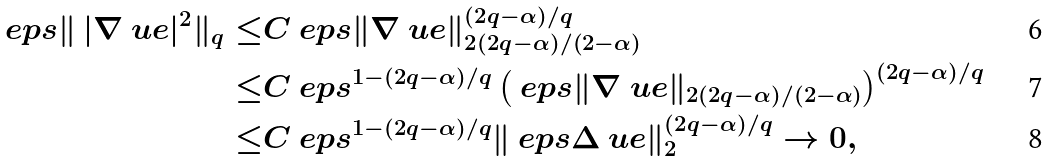Convert formula to latex. <formula><loc_0><loc_0><loc_500><loc_500>\ e p s \| \, | \nabla \ u e | ^ { 2 } \| _ { q } \leq & C \ e p s \| \nabla \ u e \| _ { 2 ( 2 q - \alpha ) / ( 2 - \alpha ) } ^ { ( 2 q - \alpha ) / q } \\ \leq & C \ e p s ^ { 1 - ( 2 q - \alpha ) / q } \left ( \ e p s \| \nabla \ u e \| _ { 2 ( 2 q - \alpha ) / ( 2 - \alpha ) } \right ) ^ { ( 2 q - \alpha ) / q } \\ \leq & C \ e p s ^ { 1 - ( 2 q - \alpha ) / q } \| \ e p s \Delta \ u e \| _ { 2 } ^ { ( 2 q - \alpha ) / q } \to 0 ,</formula> 